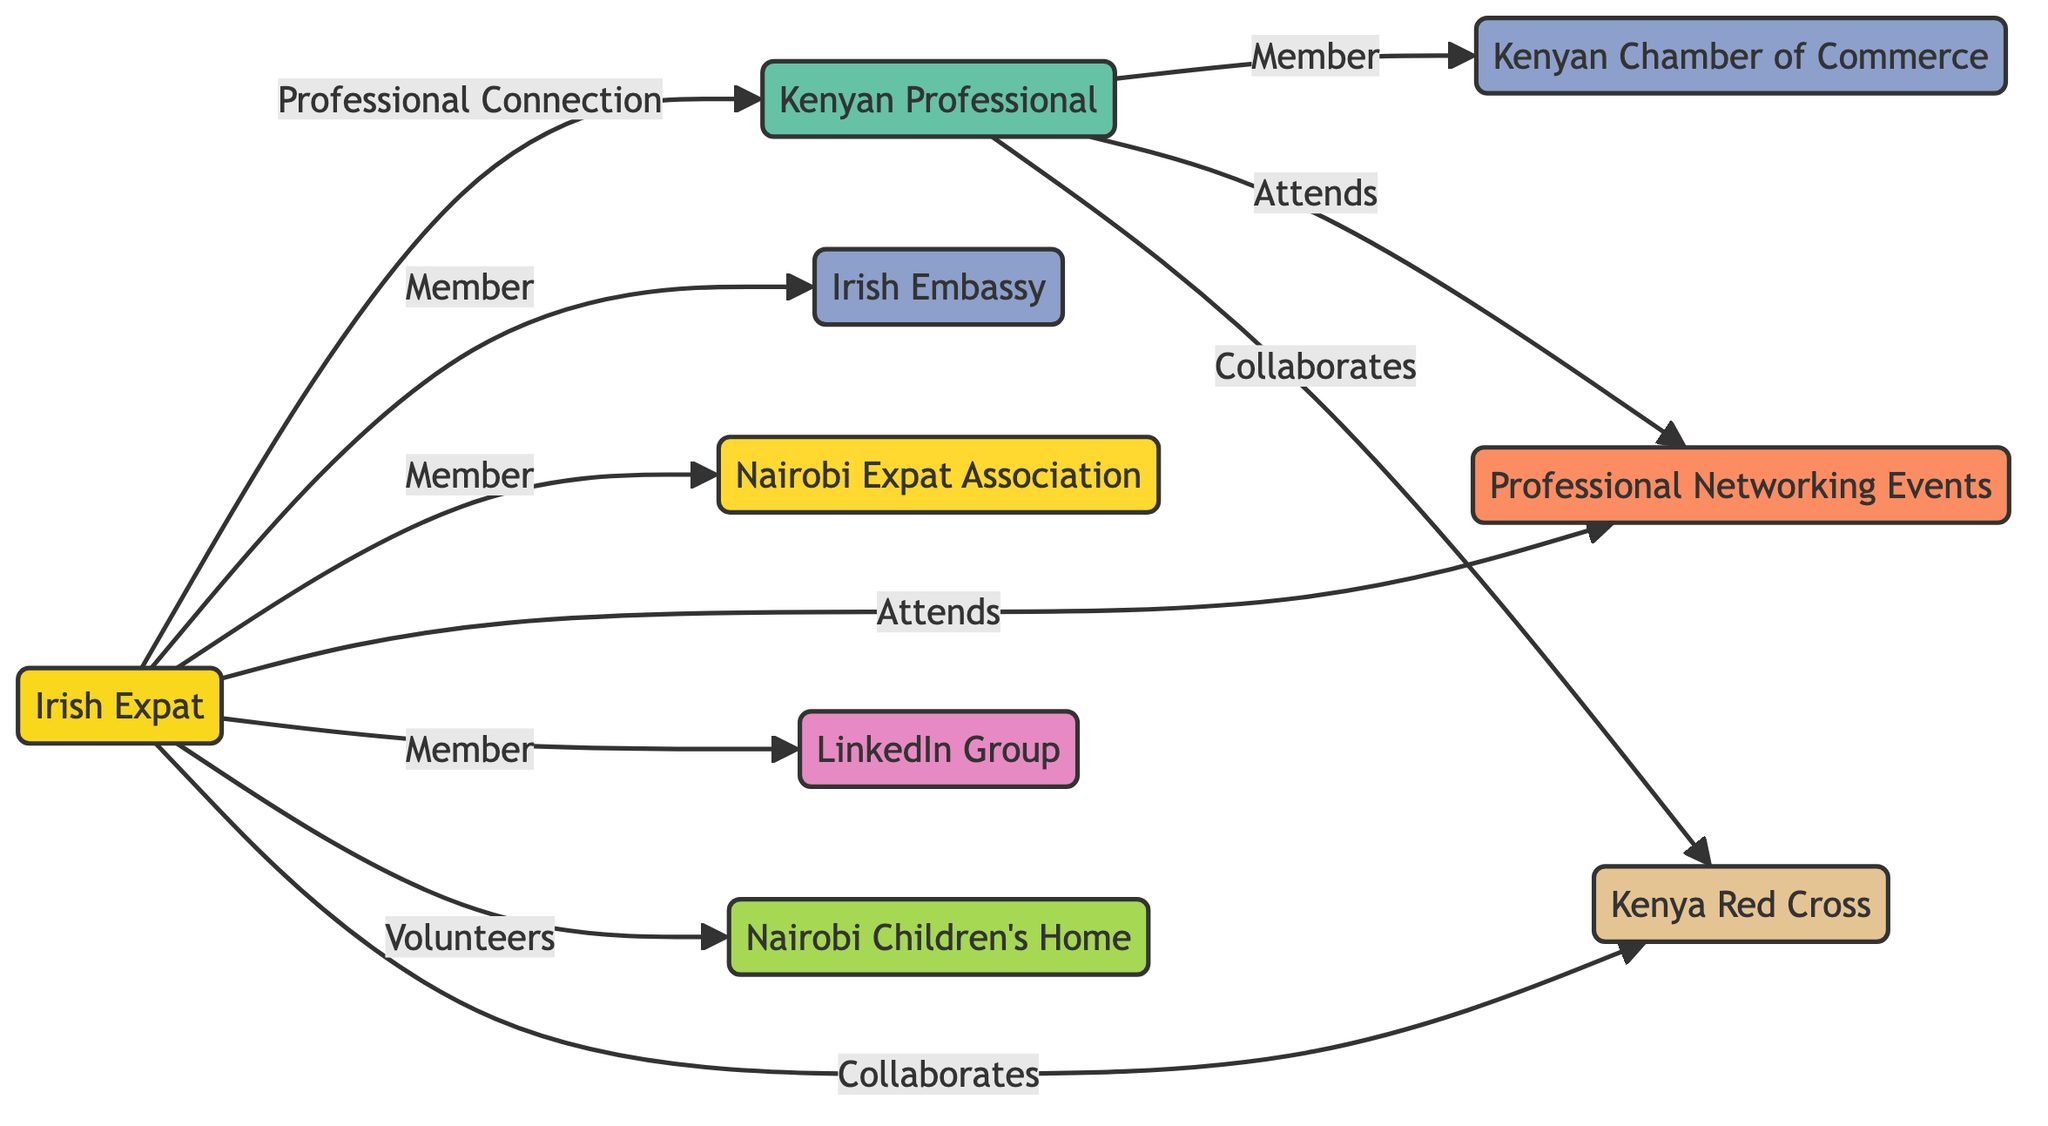What is the total number of nodes in the diagram? The diagram contains nodes representing individuals, organizations, events, and groups. By counting all listed nodes, there are 9 distinct nodes present.
Answer: 9 Who is a member of the Irish Embassy? The relationship between the Irish Expat and the Irish Embassy is indicated by the edge labeled "Member." Thus, the Irish Expat is the one connected to the Irish Embassy.
Answer: Irish Expat What type of relationship exists between the Kenyan Professional and the Nairobi Children's Home? There is no direct relationship shown between the Kenyan Professional and the Nairobi Children's Home in the diagram. Hence, the answer is none.
Answer: None How many members belong to the Nairobi Expat Association? The Irish Expat is the only member linked to the Nairobi Expat Association as per the diagram, indicated by the edge labeled "Member." So, the number of members is one.
Answer: 1 Which organization does the Kenyan Professional belong to? The Kenyan Professional is indicated to be a member of the Kenyan Chamber of Commerce, as shown by the edge labeled "Member" connecting to that organization.
Answer: Kenyan Chamber of Commerce How do the Irish Expat and Kenyan Professional collaborate with the Kenya Red Cross? Both the Irish Expat and the Kenyan Professional have edges labeled "Collaborates" connecting them to the Kenya Red Cross, meaning they work together with this NGO.
Answer: Collaborate What event do both the Irish Expat and Kenyan Professional attend? The diagram shows edges labeled "Attends" connecting both the Irish Expat and Kenyan Professional to the Professional Networking Events. The shared event is the Professional Networking Events.
Answer: Professional Networking Events What is the relationship between the Irish Expat and the LinkedIn Group? The Irish Expat is linked to the LinkedIn group by an edge labeled "Member," indicating that the Irish Expat is a member of this LinkedIn group for Irish expats.
Answer: Member Explain how the Kenyan Professional connects to the Irish Expat? The direct connection between the Kenyan Professional and the Irish Expat is shown with an edge labeled "Professional Connection," indicating a professional relationship formed between them.
Answer: Professional Connection How many edges are in the diagram? To determine the number of edges, we count the connections listed between the nodes. There are 10 edges clearly defined in the diagram.
Answer: 10 